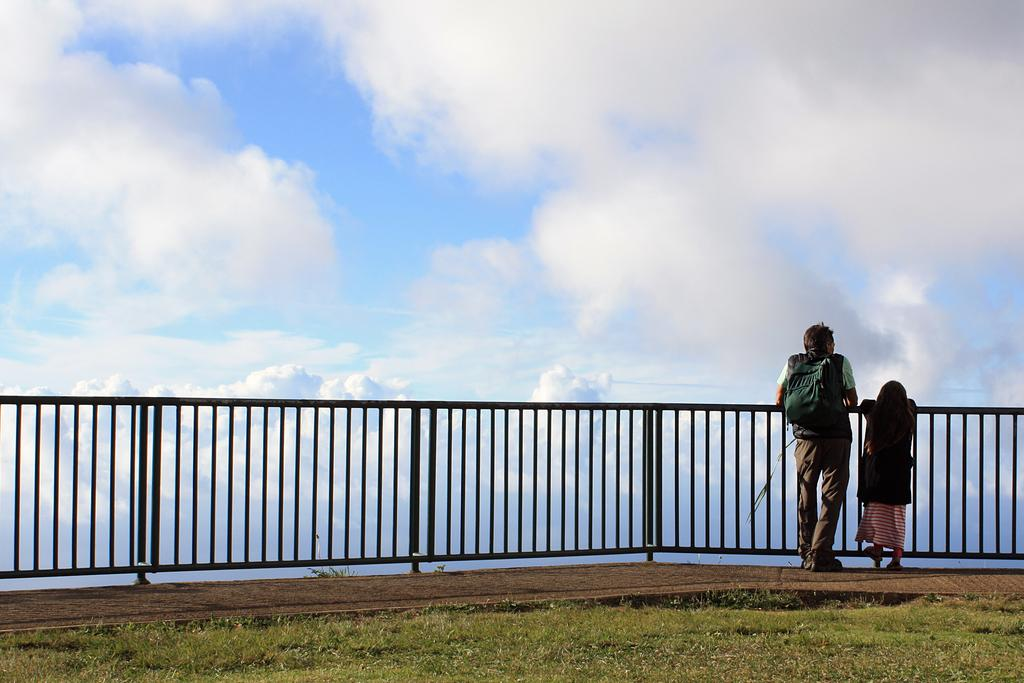How many people are present in the image? There are two people standing in the image. What is the man carrying in the image? The man is carrying a bag in the image. What type of barrier can be seen in the image? There is a fence in the image. What type of vegetation is visible in the image? There is grass in the image. What can be seen in the background of the image? The sky with clouds is visible in the background of the image. What type of wire is being used for dinner in the image? There is no wire or dinner present in the image. 